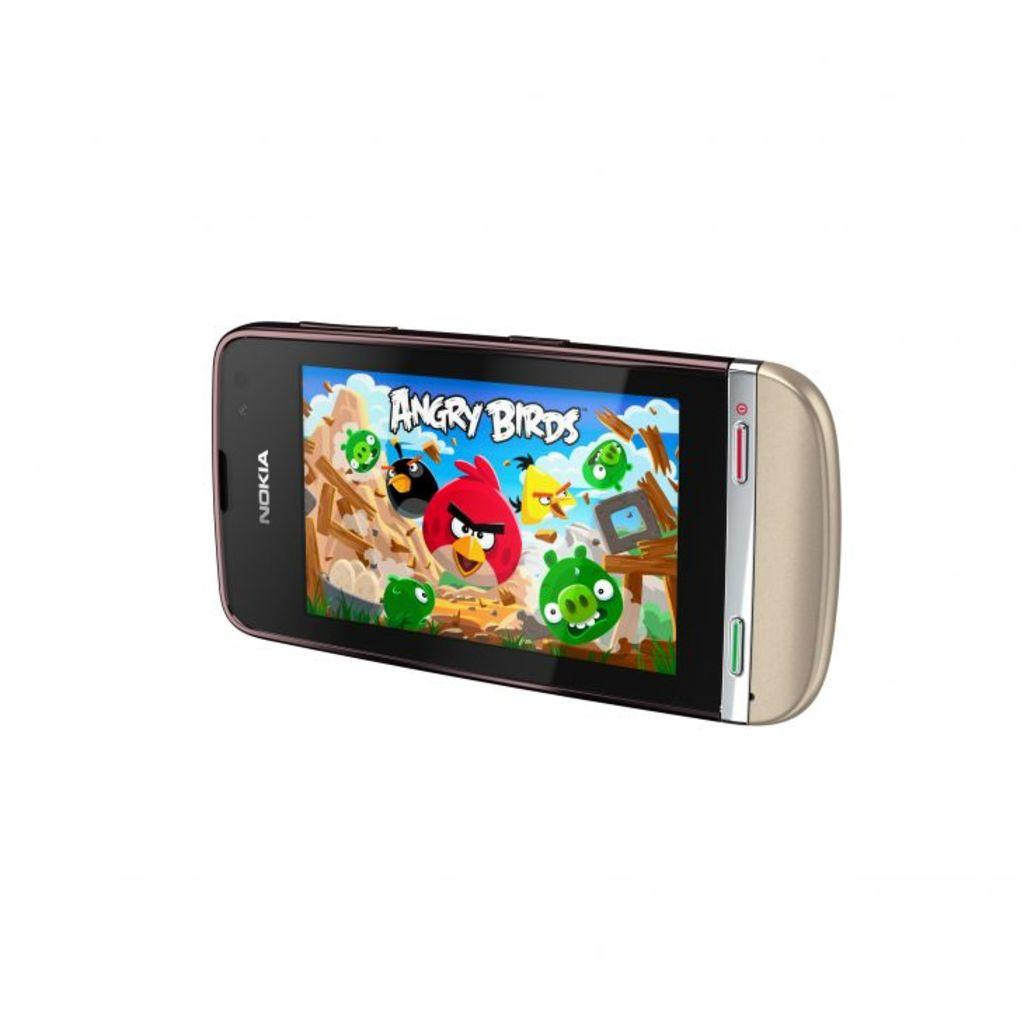<image>
Offer a succinct explanation of the picture presented. A Nokia phone with Angry Birds on the display screen. 